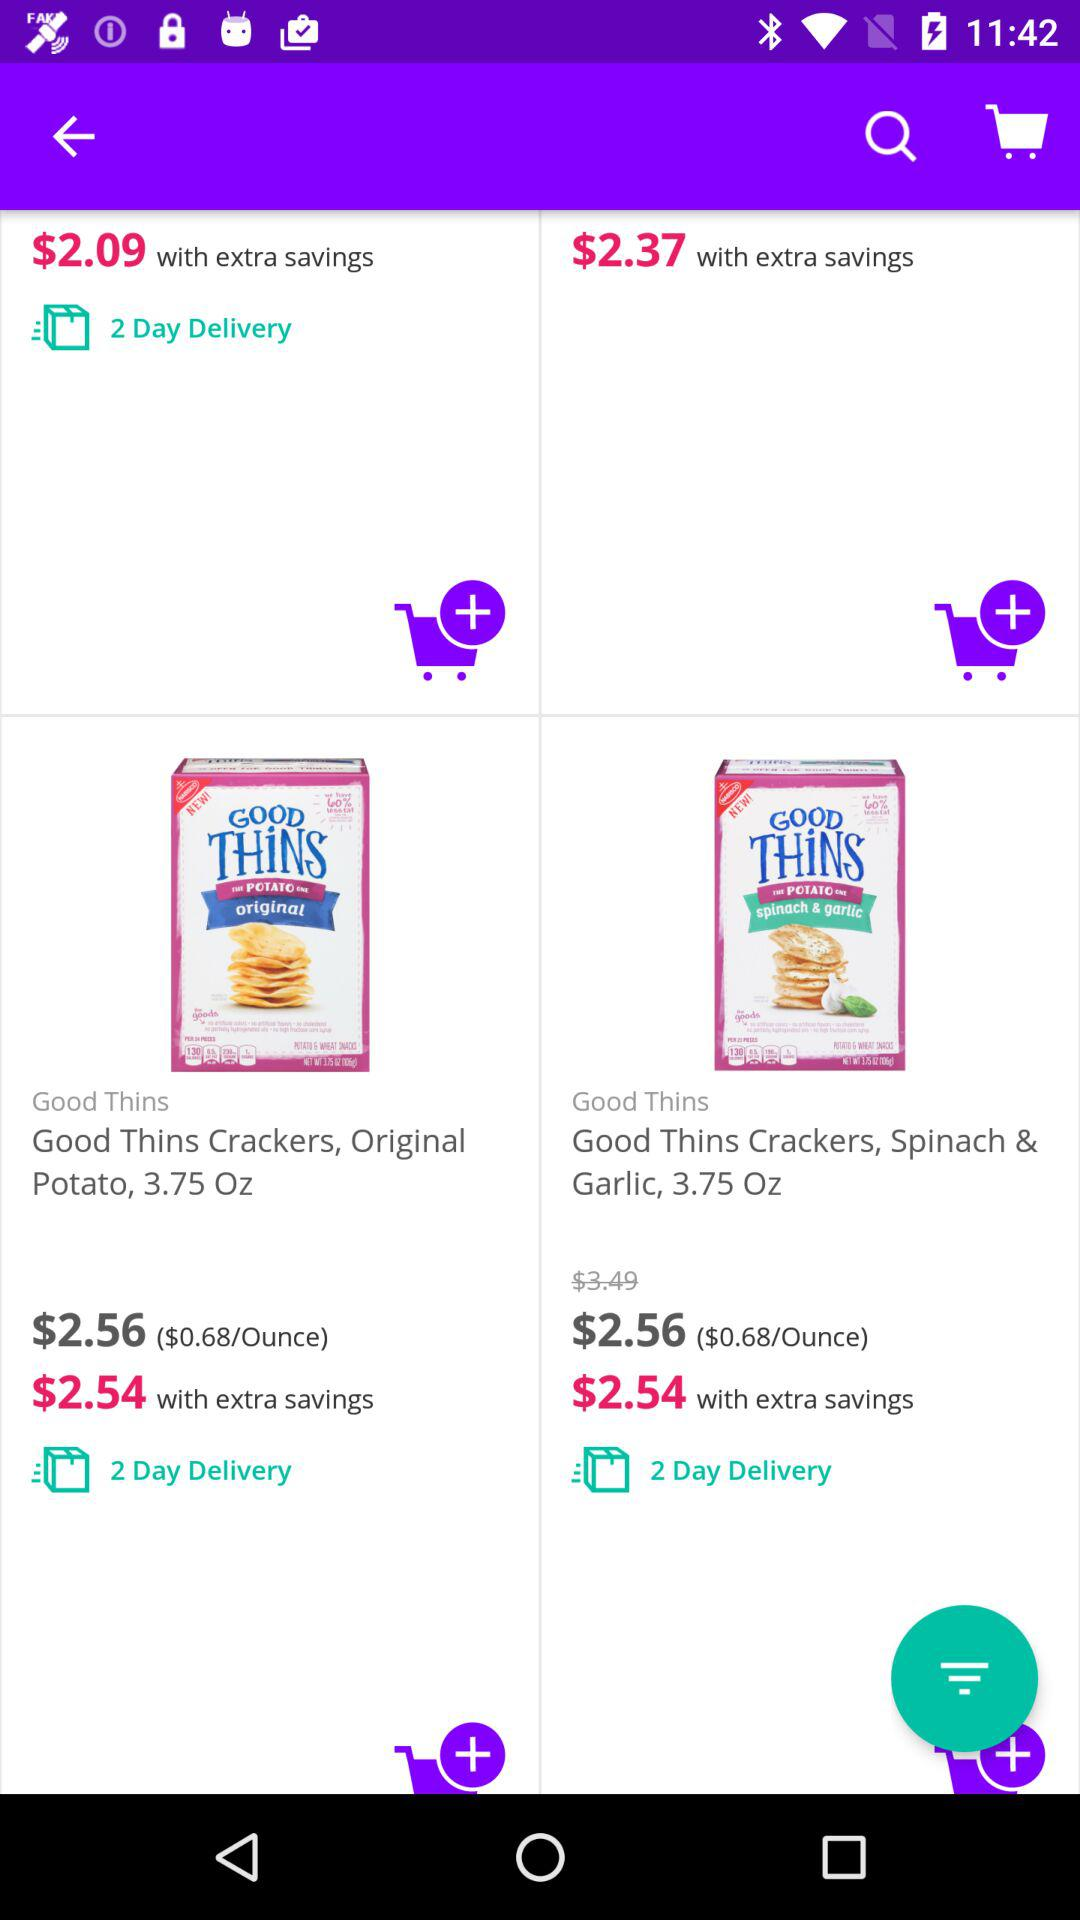What is the price of the "Good Thins Crackers, Original Potato, 3.75 Oz"? The prices are $2.56 and $2.54. 